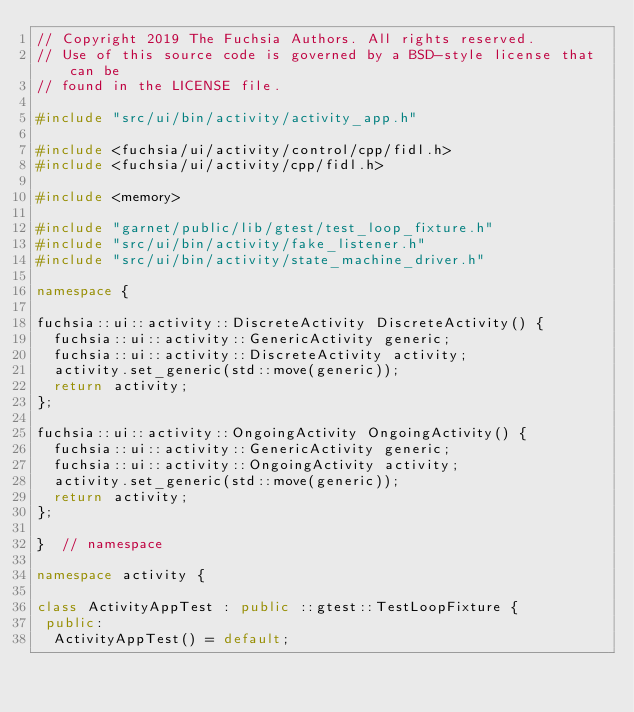<code> <loc_0><loc_0><loc_500><loc_500><_C++_>// Copyright 2019 The Fuchsia Authors. All rights reserved.
// Use of this source code is governed by a BSD-style license that can be
// found in the LICENSE file.

#include "src/ui/bin/activity/activity_app.h"

#include <fuchsia/ui/activity/control/cpp/fidl.h>
#include <fuchsia/ui/activity/cpp/fidl.h>

#include <memory>

#include "garnet/public/lib/gtest/test_loop_fixture.h"
#include "src/ui/bin/activity/fake_listener.h"
#include "src/ui/bin/activity/state_machine_driver.h"

namespace {

fuchsia::ui::activity::DiscreteActivity DiscreteActivity() {
  fuchsia::ui::activity::GenericActivity generic;
  fuchsia::ui::activity::DiscreteActivity activity;
  activity.set_generic(std::move(generic));
  return activity;
};

fuchsia::ui::activity::OngoingActivity OngoingActivity() {
  fuchsia::ui::activity::GenericActivity generic;
  fuchsia::ui::activity::OngoingActivity activity;
  activity.set_generic(std::move(generic));
  return activity;
};

}  // namespace

namespace activity {

class ActivityAppTest : public ::gtest::TestLoopFixture {
 public:
  ActivityAppTest() = default;
</code> 